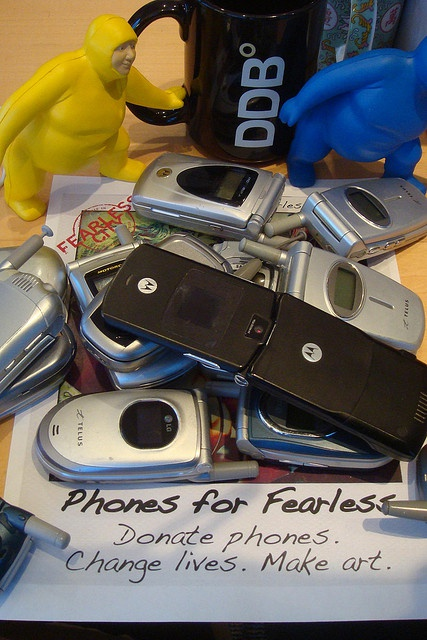Describe the objects in this image and their specific colors. I can see cell phone in tan, black, and gray tones, cup in tan, black, gray, and maroon tones, cell phone in tan, gray, black, beige, and darkgray tones, cell phone in tan, black, gray, and darkgray tones, and cell phone in tan, gray, darkgray, and black tones in this image. 